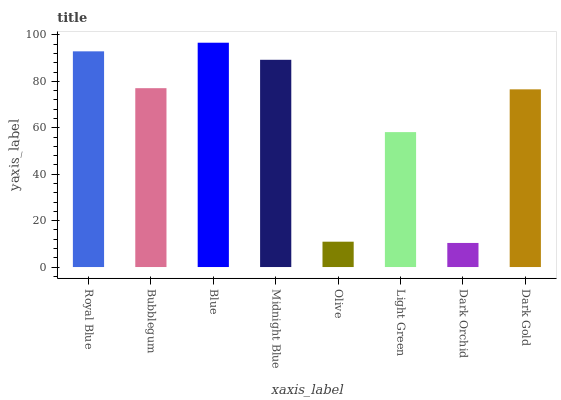Is Dark Orchid the minimum?
Answer yes or no. Yes. Is Blue the maximum?
Answer yes or no. Yes. Is Bubblegum the minimum?
Answer yes or no. No. Is Bubblegum the maximum?
Answer yes or no. No. Is Royal Blue greater than Bubblegum?
Answer yes or no. Yes. Is Bubblegum less than Royal Blue?
Answer yes or no. Yes. Is Bubblegum greater than Royal Blue?
Answer yes or no. No. Is Royal Blue less than Bubblegum?
Answer yes or no. No. Is Bubblegum the high median?
Answer yes or no. Yes. Is Dark Gold the low median?
Answer yes or no. Yes. Is Blue the high median?
Answer yes or no. No. Is Royal Blue the low median?
Answer yes or no. No. 